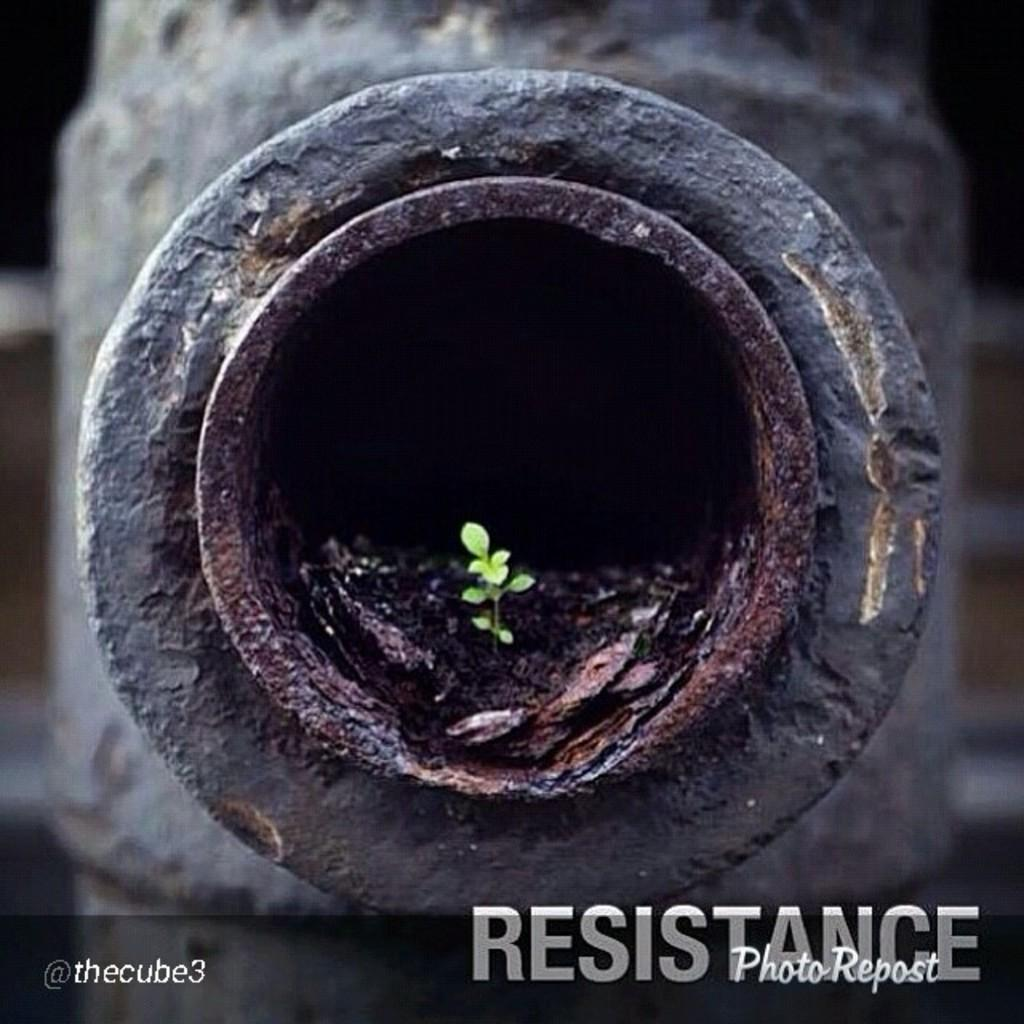What is the main object in the image? There is an iron pipe in the image. Is there anything else present in the iron pipe? Yes, there is a small plant in the hole of the iron pipe. How many legs does the ghost have in the image? There is no ghost present in the image, so it is not possible to determine how many legs it might have. 